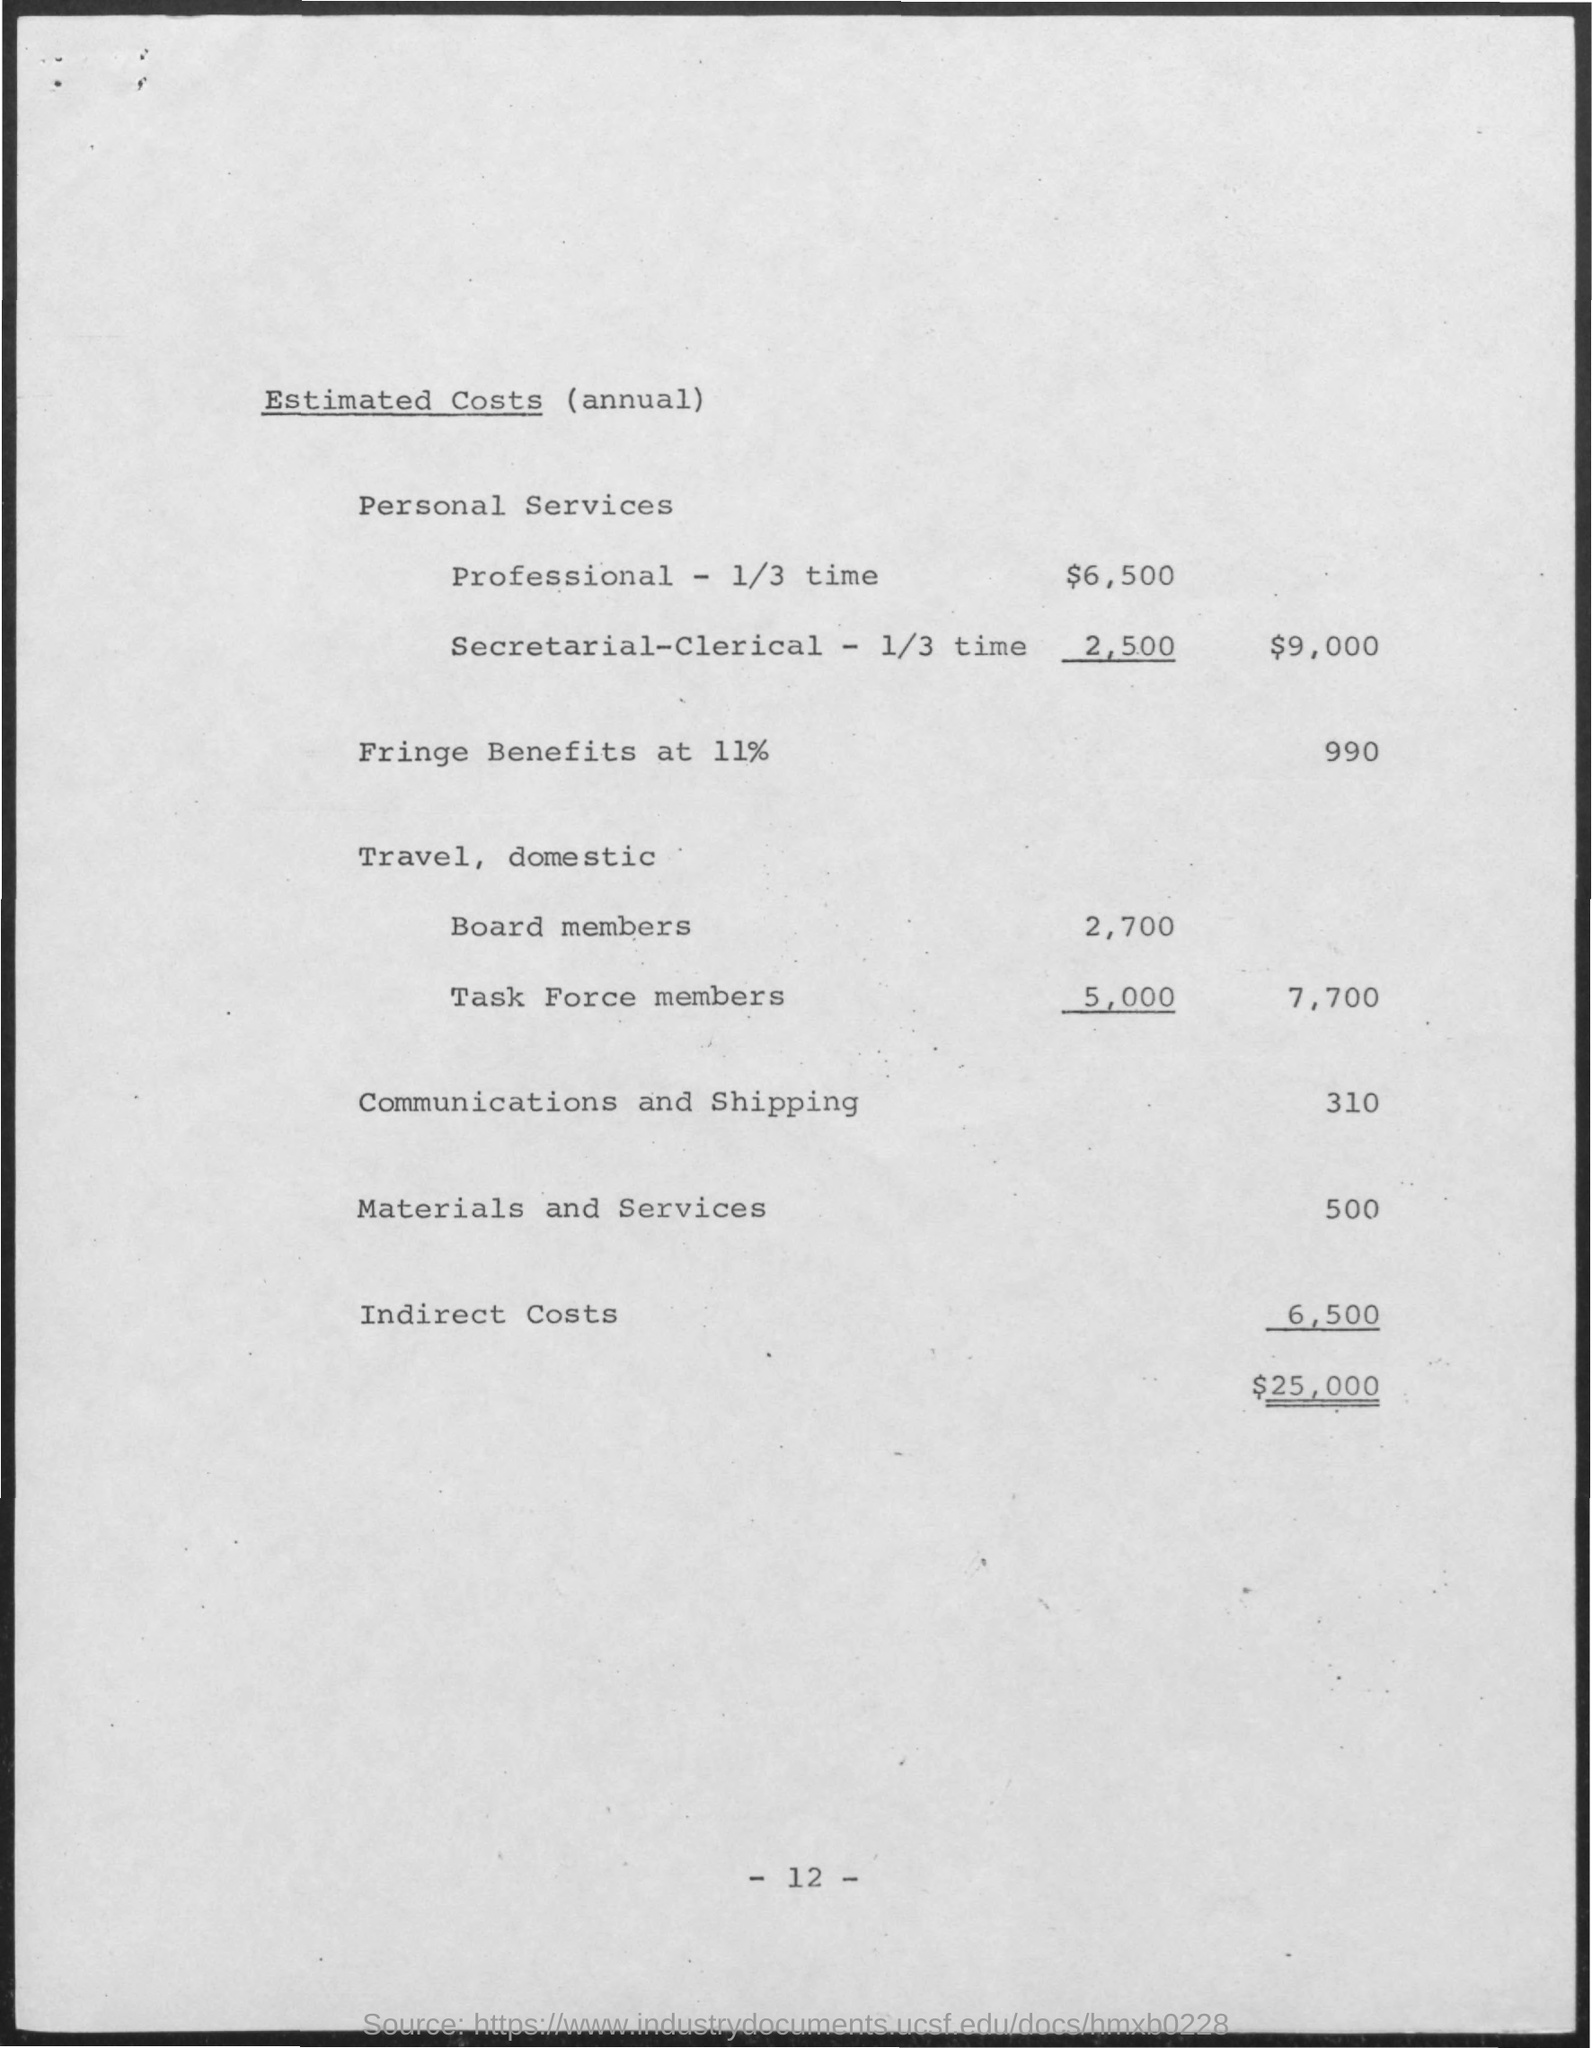Indicate a few pertinent items in this graphic. The estimated costs of communications and shipping have been mentioned to be $310. The estimated cost of indirect expenses is approximately 6,500. The estimated cost of fringe benefits at 11% is 990. The estimated cost of materials and services mentioned is approximately $500. 